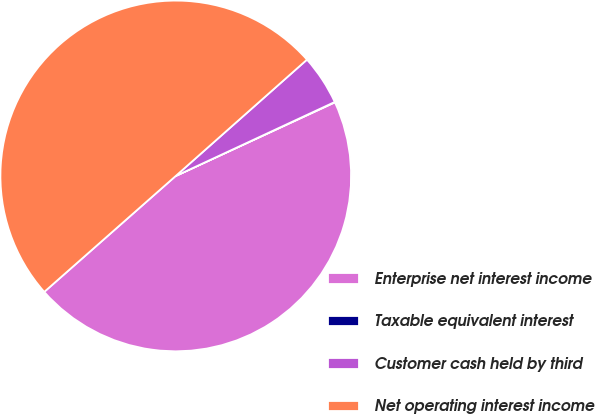<chart> <loc_0><loc_0><loc_500><loc_500><pie_chart><fcel>Enterprise net interest income<fcel>Taxable equivalent interest<fcel>Customer cash held by third<fcel>Net operating interest income<nl><fcel>45.39%<fcel>0.04%<fcel>4.61%<fcel>49.96%<nl></chart> 